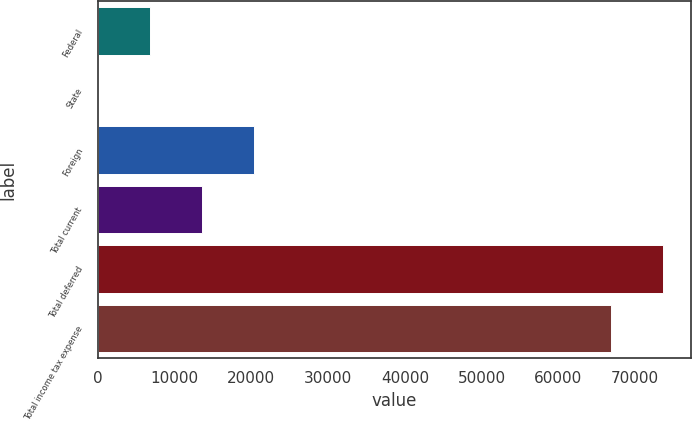<chart> <loc_0><loc_0><loc_500><loc_500><bar_chart><fcel>Federal<fcel>State<fcel>Foreign<fcel>Total current<fcel>Total deferred<fcel>Total income tax expense<nl><fcel>6827<fcel>70<fcel>20341<fcel>13584<fcel>73615<fcel>66858<nl></chart> 